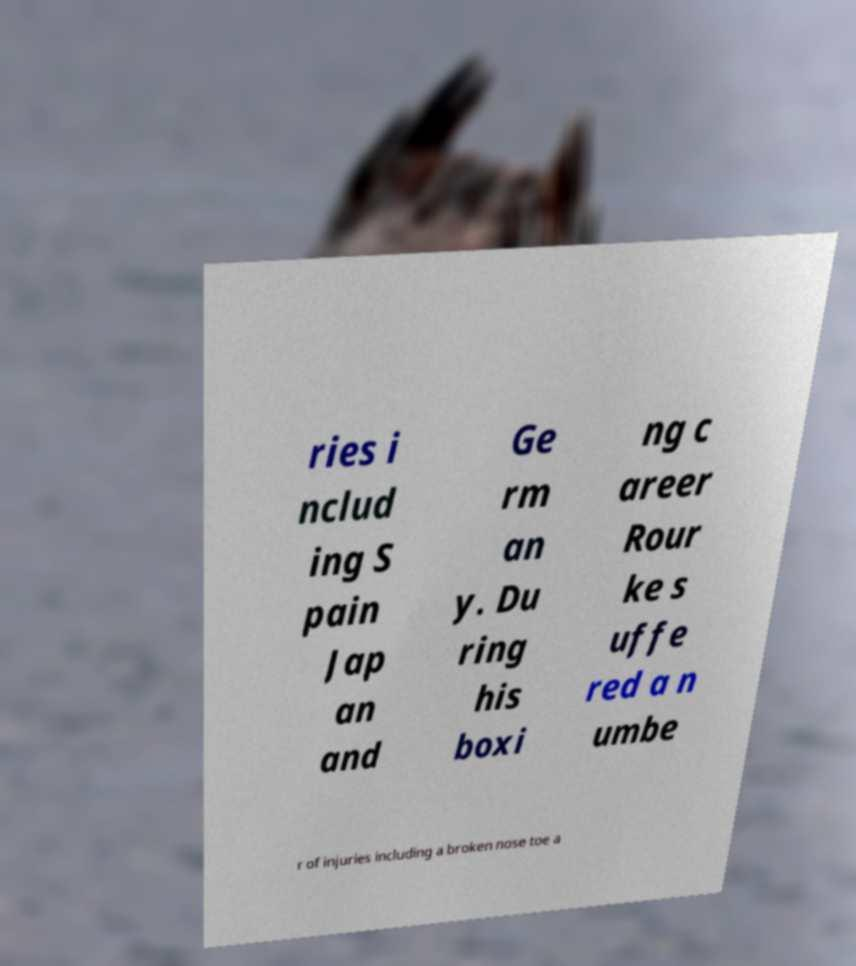For documentation purposes, I need the text within this image transcribed. Could you provide that? ries i nclud ing S pain Jap an and Ge rm an y. Du ring his boxi ng c areer Rour ke s uffe red a n umbe r of injuries including a broken nose toe a 